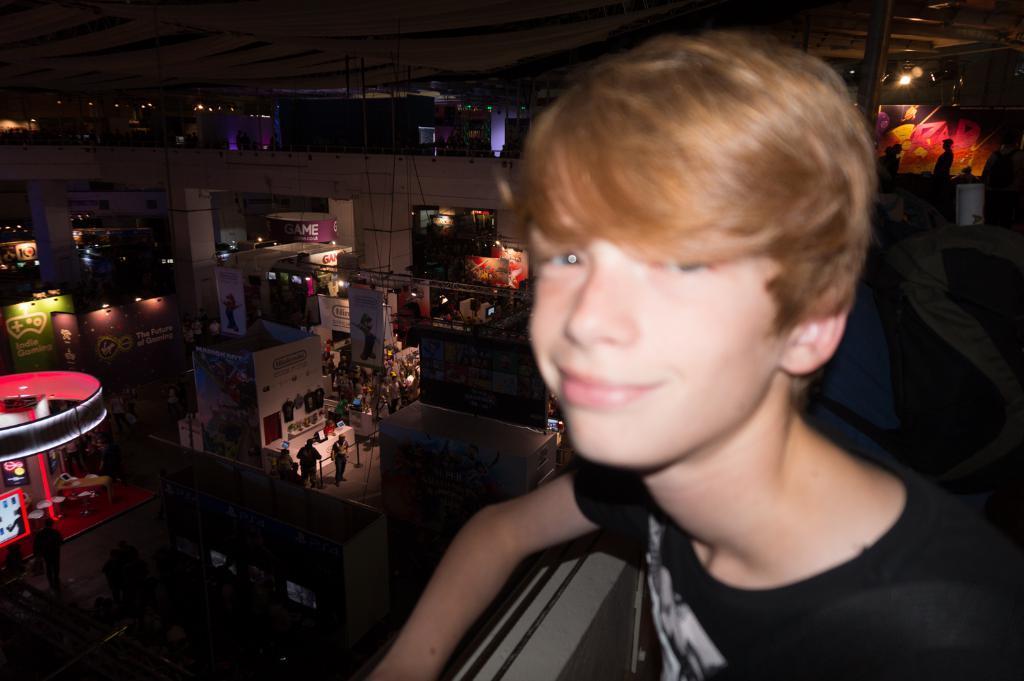Can you describe this image briefly? In this image, we can see an inside view of a building. There are some persons and banners in the middle of the image. There is a kid on the right side of the image wearing clothes. 